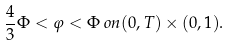Convert formula to latex. <formula><loc_0><loc_0><loc_500><loc_500>\frac { 4 } { 3 } \Phi < \varphi < \Phi \, o n ( 0 , T ) \times ( 0 , 1 ) .</formula> 